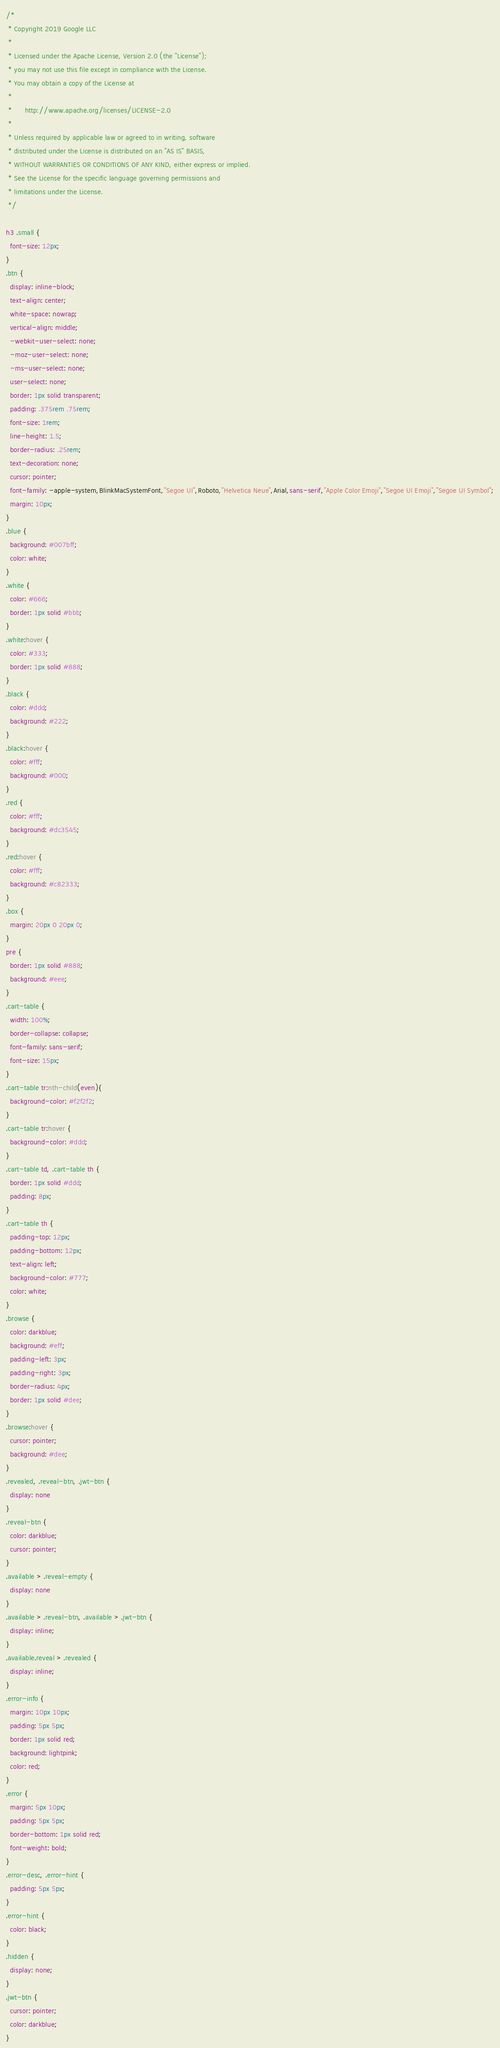Convert code to text. <code><loc_0><loc_0><loc_500><loc_500><_CSS_>/*
 * Copyright 2019 Google LLC
 *
 * Licensed under the Apache License, Version 2.0 (the "License");
 * you may not use this file except in compliance with the License.
 * You may obtain a copy of the License at
 *
 *      http://www.apache.org/licenses/LICENSE-2.0
 *
 * Unless required by applicable law or agreed to in writing, software
 * distributed under the License is distributed on an "AS IS" BASIS,
 * WITHOUT WARRANTIES OR CONDITIONS OF ANY KIND, either express or implied.
 * See the License for the specific language governing permissions and
 * limitations under the License.
 */

h3 .small {
  font-size: 12px;
}
.btn {
  display: inline-block;
  text-align: center;
  white-space: nowrap;
  vertical-align: middle;
  -webkit-user-select: none;
  -moz-user-select: none;
  -ms-user-select: none;
  user-select: none;
  border: 1px solid transparent;
  padding: .375rem .75rem;
  font-size: 1rem;
  line-height: 1.5;
  border-radius: .25rem;
  text-decoration: none;
  cursor: pointer;
  font-family: -apple-system,BlinkMacSystemFont,"Segoe UI",Roboto,"Helvetica Neue",Arial,sans-serif,"Apple Color Emoji","Segoe UI Emoji","Segoe UI Symbol";
  margin: 10px;
}
.blue {
  background: #007bff;
  color: white;
}
.white {
  color: #666;
  border: 1px solid #bbb;
}
.white:hover {
  color: #333;
  border: 1px solid #888;
}
.black {
  color: #ddd;
  background: #222;
}
.black:hover {
  color: #fff;
  background: #000;
}
.red {
  color: #fff;
  background: #dc3545;
}
.red:hover {
  color: #fff;
  background: #c82333;
}
.box {
  margin: 20px 0 20px 0;
}
pre {
  border: 1px solid #888;
  background: #eee;
}
.cart-table {
  width: 100%;
  border-collapse: collapse;
  font-family: sans-serif;
  font-size: 15px;
}
.cart-table tr:nth-child(even){
  background-color: #f2f2f2;
}
.cart-table tr:hover {
  background-color: #ddd;
}
.cart-table td, .cart-table th {
  border: 1px solid #ddd;
  padding: 8px;
}
.cart-table th {
  padding-top: 12px;
  padding-bottom: 12px;
  text-align: left;
  background-color: #777;
  color: white;
}
.browse {
  color: darkblue;
  background: #eff;
  padding-left: 3px;
  padding-right: 3px;
  border-radius: 4px;
  border: 1px solid #dee;
}
.browse:hover {
  cursor: pointer;
  background: #dee;
}
.revealed, .reveal-btn, .jwt-btn {
  display: none
}
.reveal-btn {
  color: darkblue;
  cursor: pointer;
}
.available > .reveal-empty {
  display: none
}
.available > .reveal-btn, .available > .jwt-btn {
  display: inline;
}
.available.reveal > .revealed {
  display: inline;
}
.error-info {
  margin: 10px 10px;
  padding: 5px 5px;
  border: 1px solid red;
  background: lightpink;
  color: red;
}
.error {
  margin: 5px 10px;
  padding: 5px 5px;
  border-bottom: 1px solid red;
  font-weight: bold;
}
.error-desc, .error-hint {
  padding: 5px 5px;
}
.error-hint {
  color: black;
}
.hidden {
  display: none;
}
.jwt-btn {
  cursor: pointer;
  color: darkblue;
}
</code> 